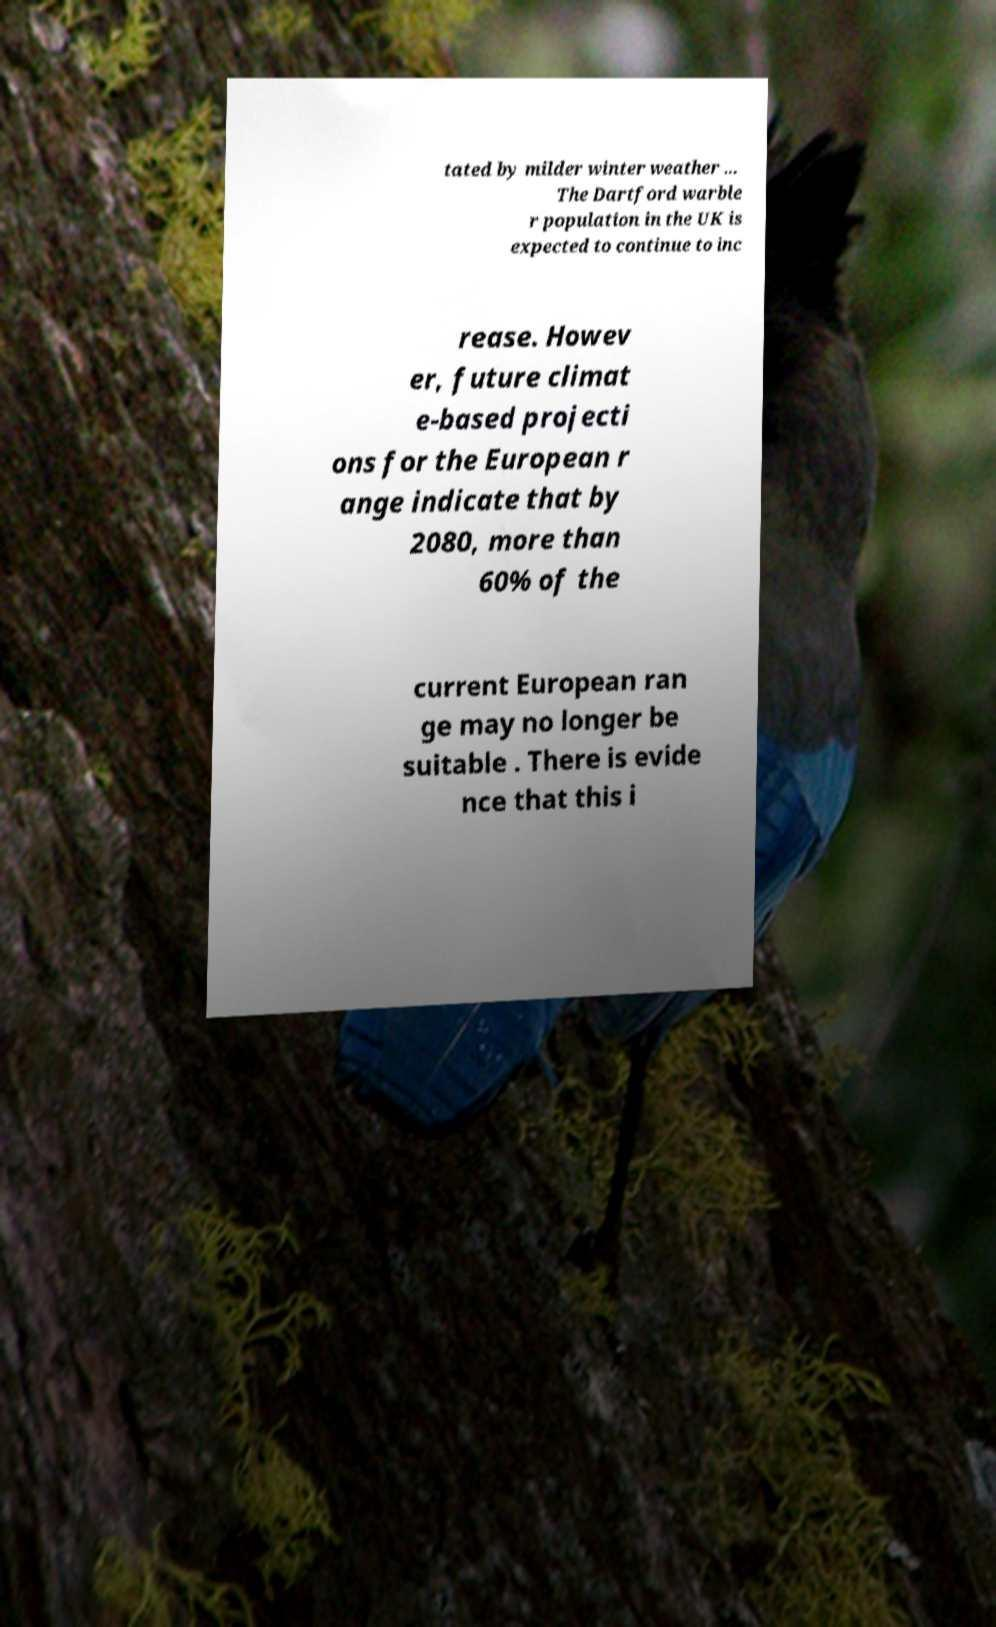I need the written content from this picture converted into text. Can you do that? tated by milder winter weather ... The Dartford warble r population in the UK is expected to continue to inc rease. Howev er, future climat e-based projecti ons for the European r ange indicate that by 2080, more than 60% of the current European ran ge may no longer be suitable . There is evide nce that this i 